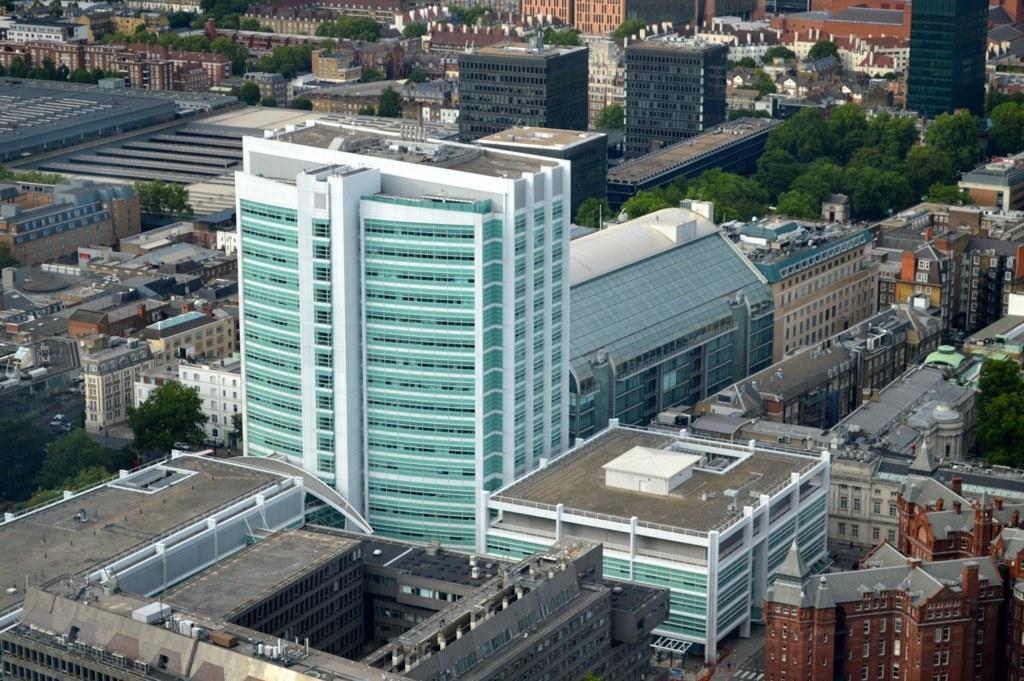Describe this image in one or two sentences. In the center of the image we can see buildings, towers, trees, windows and a few other objects. 